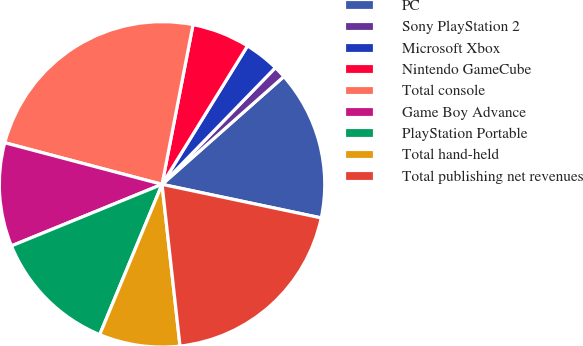Convert chart. <chart><loc_0><loc_0><loc_500><loc_500><pie_chart><fcel>PC<fcel>Sony PlayStation 2<fcel>Microsoft Xbox<fcel>Nintendo GameCube<fcel>Total console<fcel>Game Boy Advance<fcel>PlayStation Portable<fcel>Total hand-held<fcel>Total publishing net revenues<nl><fcel>14.84%<fcel>1.2%<fcel>3.47%<fcel>5.75%<fcel>23.93%<fcel>10.29%<fcel>12.57%<fcel>8.02%<fcel>19.93%<nl></chart> 